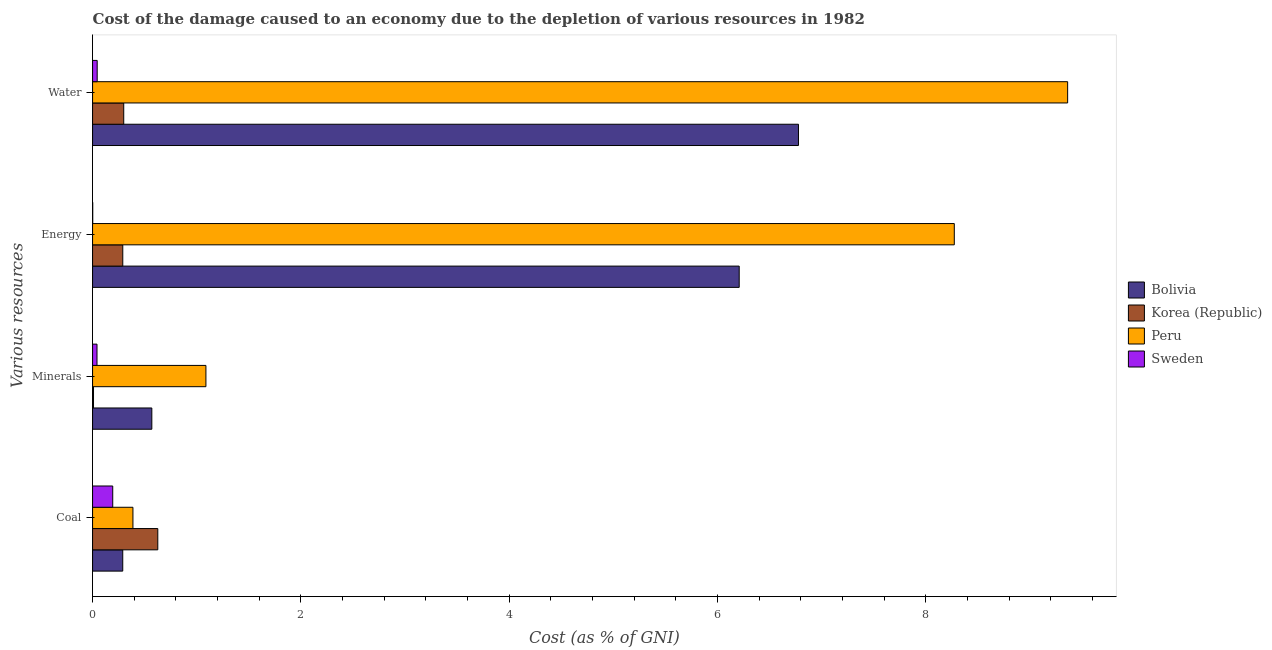How many groups of bars are there?
Ensure brevity in your answer.  4. How many bars are there on the 4th tick from the bottom?
Offer a very short reply. 4. What is the label of the 2nd group of bars from the top?
Your answer should be compact. Energy. What is the cost of damage due to depletion of minerals in Peru?
Your answer should be compact. 1.09. Across all countries, what is the maximum cost of damage due to depletion of energy?
Your response must be concise. 8.27. Across all countries, what is the minimum cost of damage due to depletion of minerals?
Keep it short and to the point. 0.01. What is the total cost of damage due to depletion of coal in the graph?
Provide a short and direct response. 1.5. What is the difference between the cost of damage due to depletion of water in Sweden and that in Bolivia?
Make the answer very short. -6.73. What is the difference between the cost of damage due to depletion of minerals in Sweden and the cost of damage due to depletion of water in Korea (Republic)?
Make the answer very short. -0.26. What is the average cost of damage due to depletion of minerals per country?
Your answer should be very brief. 0.43. What is the difference between the cost of damage due to depletion of energy and cost of damage due to depletion of coal in Bolivia?
Give a very brief answer. 5.92. What is the ratio of the cost of damage due to depletion of energy in Sweden to that in Korea (Republic)?
Your response must be concise. 0.01. What is the difference between the highest and the second highest cost of damage due to depletion of energy?
Make the answer very short. 2.06. What is the difference between the highest and the lowest cost of damage due to depletion of coal?
Provide a short and direct response. 0.43. In how many countries, is the cost of damage due to depletion of minerals greater than the average cost of damage due to depletion of minerals taken over all countries?
Provide a succinct answer. 2. Is it the case that in every country, the sum of the cost of damage due to depletion of minerals and cost of damage due to depletion of coal is greater than the sum of cost of damage due to depletion of water and cost of damage due to depletion of energy?
Keep it short and to the point. No. What does the 2nd bar from the top in Water represents?
Offer a very short reply. Peru. Is it the case that in every country, the sum of the cost of damage due to depletion of coal and cost of damage due to depletion of minerals is greater than the cost of damage due to depletion of energy?
Your response must be concise. No. How many bars are there?
Your response must be concise. 16. How many countries are there in the graph?
Offer a very short reply. 4. What is the difference between two consecutive major ticks on the X-axis?
Offer a terse response. 2. Are the values on the major ticks of X-axis written in scientific E-notation?
Give a very brief answer. No. Does the graph contain any zero values?
Provide a succinct answer. No. Does the graph contain grids?
Keep it short and to the point. No. How are the legend labels stacked?
Offer a terse response. Vertical. What is the title of the graph?
Your answer should be compact. Cost of the damage caused to an economy due to the depletion of various resources in 1982 . Does "Finland" appear as one of the legend labels in the graph?
Offer a very short reply. No. What is the label or title of the X-axis?
Your answer should be very brief. Cost (as % of GNI). What is the label or title of the Y-axis?
Give a very brief answer. Various resources. What is the Cost (as % of GNI) of Bolivia in Coal?
Your answer should be compact. 0.29. What is the Cost (as % of GNI) in Korea (Republic) in Coal?
Offer a terse response. 0.63. What is the Cost (as % of GNI) in Peru in Coal?
Offer a very short reply. 0.39. What is the Cost (as % of GNI) of Sweden in Coal?
Ensure brevity in your answer.  0.19. What is the Cost (as % of GNI) of Bolivia in Minerals?
Keep it short and to the point. 0.57. What is the Cost (as % of GNI) in Korea (Republic) in Minerals?
Keep it short and to the point. 0.01. What is the Cost (as % of GNI) in Peru in Minerals?
Keep it short and to the point. 1.09. What is the Cost (as % of GNI) in Sweden in Minerals?
Offer a terse response. 0.04. What is the Cost (as % of GNI) of Bolivia in Energy?
Give a very brief answer. 6.21. What is the Cost (as % of GNI) of Korea (Republic) in Energy?
Offer a very short reply. 0.29. What is the Cost (as % of GNI) in Peru in Energy?
Offer a terse response. 8.27. What is the Cost (as % of GNI) in Sweden in Energy?
Provide a succinct answer. 0. What is the Cost (as % of GNI) of Bolivia in Water?
Your answer should be very brief. 6.78. What is the Cost (as % of GNI) of Korea (Republic) in Water?
Your answer should be very brief. 0.3. What is the Cost (as % of GNI) in Peru in Water?
Provide a short and direct response. 9.36. What is the Cost (as % of GNI) of Sweden in Water?
Keep it short and to the point. 0.04. Across all Various resources, what is the maximum Cost (as % of GNI) in Bolivia?
Give a very brief answer. 6.78. Across all Various resources, what is the maximum Cost (as % of GNI) of Korea (Republic)?
Give a very brief answer. 0.63. Across all Various resources, what is the maximum Cost (as % of GNI) of Peru?
Keep it short and to the point. 9.36. Across all Various resources, what is the maximum Cost (as % of GNI) in Sweden?
Give a very brief answer. 0.19. Across all Various resources, what is the minimum Cost (as % of GNI) in Bolivia?
Provide a short and direct response. 0.29. Across all Various resources, what is the minimum Cost (as % of GNI) in Korea (Republic)?
Your answer should be very brief. 0.01. Across all Various resources, what is the minimum Cost (as % of GNI) in Peru?
Provide a succinct answer. 0.39. Across all Various resources, what is the minimum Cost (as % of GNI) of Sweden?
Your response must be concise. 0. What is the total Cost (as % of GNI) of Bolivia in the graph?
Provide a succinct answer. 13.84. What is the total Cost (as % of GNI) in Korea (Republic) in the graph?
Your answer should be very brief. 1.22. What is the total Cost (as % of GNI) in Peru in the graph?
Keep it short and to the point. 19.11. What is the total Cost (as % of GNI) of Sweden in the graph?
Your answer should be very brief. 0.28. What is the difference between the Cost (as % of GNI) in Bolivia in Coal and that in Minerals?
Make the answer very short. -0.28. What is the difference between the Cost (as % of GNI) of Korea (Republic) in Coal and that in Minerals?
Provide a short and direct response. 0.62. What is the difference between the Cost (as % of GNI) of Peru in Coal and that in Minerals?
Ensure brevity in your answer.  -0.7. What is the difference between the Cost (as % of GNI) in Sweden in Coal and that in Minerals?
Offer a terse response. 0.15. What is the difference between the Cost (as % of GNI) of Bolivia in Coal and that in Energy?
Make the answer very short. -5.92. What is the difference between the Cost (as % of GNI) in Korea (Republic) in Coal and that in Energy?
Provide a short and direct response. 0.34. What is the difference between the Cost (as % of GNI) in Peru in Coal and that in Energy?
Make the answer very short. -7.88. What is the difference between the Cost (as % of GNI) of Sweden in Coal and that in Energy?
Keep it short and to the point. 0.19. What is the difference between the Cost (as % of GNI) of Bolivia in Coal and that in Water?
Give a very brief answer. -6.49. What is the difference between the Cost (as % of GNI) in Korea (Republic) in Coal and that in Water?
Provide a succinct answer. 0.33. What is the difference between the Cost (as % of GNI) in Peru in Coal and that in Water?
Offer a very short reply. -8.97. What is the difference between the Cost (as % of GNI) of Sweden in Coal and that in Water?
Keep it short and to the point. 0.15. What is the difference between the Cost (as % of GNI) in Bolivia in Minerals and that in Energy?
Your response must be concise. -5.64. What is the difference between the Cost (as % of GNI) of Korea (Republic) in Minerals and that in Energy?
Your response must be concise. -0.28. What is the difference between the Cost (as % of GNI) in Peru in Minerals and that in Energy?
Offer a very short reply. -7.18. What is the difference between the Cost (as % of GNI) in Sweden in Minerals and that in Energy?
Keep it short and to the point. 0.04. What is the difference between the Cost (as % of GNI) of Bolivia in Minerals and that in Water?
Your answer should be compact. -6.21. What is the difference between the Cost (as % of GNI) in Korea (Republic) in Minerals and that in Water?
Provide a short and direct response. -0.29. What is the difference between the Cost (as % of GNI) of Peru in Minerals and that in Water?
Your answer should be compact. -8.27. What is the difference between the Cost (as % of GNI) of Sweden in Minerals and that in Water?
Offer a very short reply. -0. What is the difference between the Cost (as % of GNI) of Bolivia in Energy and that in Water?
Make the answer very short. -0.57. What is the difference between the Cost (as % of GNI) in Korea (Republic) in Energy and that in Water?
Give a very brief answer. -0.01. What is the difference between the Cost (as % of GNI) in Peru in Energy and that in Water?
Your answer should be very brief. -1.09. What is the difference between the Cost (as % of GNI) of Sweden in Energy and that in Water?
Keep it short and to the point. -0.04. What is the difference between the Cost (as % of GNI) in Bolivia in Coal and the Cost (as % of GNI) in Korea (Republic) in Minerals?
Your response must be concise. 0.28. What is the difference between the Cost (as % of GNI) in Bolivia in Coal and the Cost (as % of GNI) in Peru in Minerals?
Make the answer very short. -0.8. What is the difference between the Cost (as % of GNI) of Bolivia in Coal and the Cost (as % of GNI) of Sweden in Minerals?
Offer a very short reply. 0.25. What is the difference between the Cost (as % of GNI) in Korea (Republic) in Coal and the Cost (as % of GNI) in Peru in Minerals?
Your answer should be compact. -0.46. What is the difference between the Cost (as % of GNI) in Korea (Republic) in Coal and the Cost (as % of GNI) in Sweden in Minerals?
Offer a very short reply. 0.58. What is the difference between the Cost (as % of GNI) in Peru in Coal and the Cost (as % of GNI) in Sweden in Minerals?
Keep it short and to the point. 0.34. What is the difference between the Cost (as % of GNI) in Bolivia in Coal and the Cost (as % of GNI) in Korea (Republic) in Energy?
Keep it short and to the point. -0. What is the difference between the Cost (as % of GNI) in Bolivia in Coal and the Cost (as % of GNI) in Peru in Energy?
Offer a terse response. -7.98. What is the difference between the Cost (as % of GNI) in Bolivia in Coal and the Cost (as % of GNI) in Sweden in Energy?
Your answer should be compact. 0.29. What is the difference between the Cost (as % of GNI) in Korea (Republic) in Coal and the Cost (as % of GNI) in Peru in Energy?
Offer a terse response. -7.65. What is the difference between the Cost (as % of GNI) in Korea (Republic) in Coal and the Cost (as % of GNI) in Sweden in Energy?
Provide a short and direct response. 0.62. What is the difference between the Cost (as % of GNI) of Peru in Coal and the Cost (as % of GNI) of Sweden in Energy?
Provide a short and direct response. 0.39. What is the difference between the Cost (as % of GNI) in Bolivia in Coal and the Cost (as % of GNI) in Korea (Republic) in Water?
Make the answer very short. -0.01. What is the difference between the Cost (as % of GNI) in Bolivia in Coal and the Cost (as % of GNI) in Peru in Water?
Give a very brief answer. -9.07. What is the difference between the Cost (as % of GNI) in Bolivia in Coal and the Cost (as % of GNI) in Sweden in Water?
Provide a short and direct response. 0.25. What is the difference between the Cost (as % of GNI) in Korea (Republic) in Coal and the Cost (as % of GNI) in Peru in Water?
Your answer should be compact. -8.73. What is the difference between the Cost (as % of GNI) of Korea (Republic) in Coal and the Cost (as % of GNI) of Sweden in Water?
Offer a very short reply. 0.58. What is the difference between the Cost (as % of GNI) of Peru in Coal and the Cost (as % of GNI) of Sweden in Water?
Offer a terse response. 0.34. What is the difference between the Cost (as % of GNI) of Bolivia in Minerals and the Cost (as % of GNI) of Korea (Republic) in Energy?
Give a very brief answer. 0.28. What is the difference between the Cost (as % of GNI) of Bolivia in Minerals and the Cost (as % of GNI) of Peru in Energy?
Keep it short and to the point. -7.7. What is the difference between the Cost (as % of GNI) in Bolivia in Minerals and the Cost (as % of GNI) in Sweden in Energy?
Offer a terse response. 0.57. What is the difference between the Cost (as % of GNI) of Korea (Republic) in Minerals and the Cost (as % of GNI) of Peru in Energy?
Give a very brief answer. -8.26. What is the difference between the Cost (as % of GNI) in Korea (Republic) in Minerals and the Cost (as % of GNI) in Sweden in Energy?
Offer a very short reply. 0.01. What is the difference between the Cost (as % of GNI) of Peru in Minerals and the Cost (as % of GNI) of Sweden in Energy?
Your answer should be very brief. 1.09. What is the difference between the Cost (as % of GNI) in Bolivia in Minerals and the Cost (as % of GNI) in Korea (Republic) in Water?
Keep it short and to the point. 0.27. What is the difference between the Cost (as % of GNI) of Bolivia in Minerals and the Cost (as % of GNI) of Peru in Water?
Provide a succinct answer. -8.79. What is the difference between the Cost (as % of GNI) of Bolivia in Minerals and the Cost (as % of GNI) of Sweden in Water?
Provide a short and direct response. 0.52. What is the difference between the Cost (as % of GNI) of Korea (Republic) in Minerals and the Cost (as % of GNI) of Peru in Water?
Provide a succinct answer. -9.35. What is the difference between the Cost (as % of GNI) of Korea (Republic) in Minerals and the Cost (as % of GNI) of Sweden in Water?
Give a very brief answer. -0.04. What is the difference between the Cost (as % of GNI) in Peru in Minerals and the Cost (as % of GNI) in Sweden in Water?
Offer a very short reply. 1.04. What is the difference between the Cost (as % of GNI) of Bolivia in Energy and the Cost (as % of GNI) of Korea (Republic) in Water?
Offer a terse response. 5.91. What is the difference between the Cost (as % of GNI) of Bolivia in Energy and the Cost (as % of GNI) of Peru in Water?
Ensure brevity in your answer.  -3.15. What is the difference between the Cost (as % of GNI) in Bolivia in Energy and the Cost (as % of GNI) in Sweden in Water?
Your answer should be compact. 6.16. What is the difference between the Cost (as % of GNI) of Korea (Republic) in Energy and the Cost (as % of GNI) of Peru in Water?
Give a very brief answer. -9.07. What is the difference between the Cost (as % of GNI) in Korea (Republic) in Energy and the Cost (as % of GNI) in Sweden in Water?
Give a very brief answer. 0.25. What is the difference between the Cost (as % of GNI) of Peru in Energy and the Cost (as % of GNI) of Sweden in Water?
Offer a terse response. 8.23. What is the average Cost (as % of GNI) in Bolivia per Various resources?
Keep it short and to the point. 3.46. What is the average Cost (as % of GNI) in Korea (Republic) per Various resources?
Make the answer very short. 0.31. What is the average Cost (as % of GNI) of Peru per Various resources?
Ensure brevity in your answer.  4.78. What is the average Cost (as % of GNI) of Sweden per Various resources?
Your answer should be compact. 0.07. What is the difference between the Cost (as % of GNI) of Bolivia and Cost (as % of GNI) of Korea (Republic) in Coal?
Offer a terse response. -0.34. What is the difference between the Cost (as % of GNI) of Bolivia and Cost (as % of GNI) of Peru in Coal?
Your answer should be very brief. -0.1. What is the difference between the Cost (as % of GNI) of Bolivia and Cost (as % of GNI) of Sweden in Coal?
Give a very brief answer. 0.1. What is the difference between the Cost (as % of GNI) of Korea (Republic) and Cost (as % of GNI) of Peru in Coal?
Your answer should be compact. 0.24. What is the difference between the Cost (as % of GNI) in Korea (Republic) and Cost (as % of GNI) in Sweden in Coal?
Keep it short and to the point. 0.43. What is the difference between the Cost (as % of GNI) of Peru and Cost (as % of GNI) of Sweden in Coal?
Offer a very short reply. 0.19. What is the difference between the Cost (as % of GNI) in Bolivia and Cost (as % of GNI) in Korea (Republic) in Minerals?
Make the answer very short. 0.56. What is the difference between the Cost (as % of GNI) in Bolivia and Cost (as % of GNI) in Peru in Minerals?
Your answer should be compact. -0.52. What is the difference between the Cost (as % of GNI) of Bolivia and Cost (as % of GNI) of Sweden in Minerals?
Offer a terse response. 0.53. What is the difference between the Cost (as % of GNI) in Korea (Republic) and Cost (as % of GNI) in Peru in Minerals?
Ensure brevity in your answer.  -1.08. What is the difference between the Cost (as % of GNI) of Korea (Republic) and Cost (as % of GNI) of Sweden in Minerals?
Ensure brevity in your answer.  -0.03. What is the difference between the Cost (as % of GNI) in Peru and Cost (as % of GNI) in Sweden in Minerals?
Give a very brief answer. 1.05. What is the difference between the Cost (as % of GNI) of Bolivia and Cost (as % of GNI) of Korea (Republic) in Energy?
Provide a succinct answer. 5.92. What is the difference between the Cost (as % of GNI) of Bolivia and Cost (as % of GNI) of Peru in Energy?
Provide a short and direct response. -2.06. What is the difference between the Cost (as % of GNI) in Bolivia and Cost (as % of GNI) in Sweden in Energy?
Your response must be concise. 6.21. What is the difference between the Cost (as % of GNI) of Korea (Republic) and Cost (as % of GNI) of Peru in Energy?
Offer a terse response. -7.98. What is the difference between the Cost (as % of GNI) in Korea (Republic) and Cost (as % of GNI) in Sweden in Energy?
Your answer should be compact. 0.29. What is the difference between the Cost (as % of GNI) in Peru and Cost (as % of GNI) in Sweden in Energy?
Keep it short and to the point. 8.27. What is the difference between the Cost (as % of GNI) of Bolivia and Cost (as % of GNI) of Korea (Republic) in Water?
Your answer should be very brief. 6.48. What is the difference between the Cost (as % of GNI) in Bolivia and Cost (as % of GNI) in Peru in Water?
Give a very brief answer. -2.58. What is the difference between the Cost (as % of GNI) in Bolivia and Cost (as % of GNI) in Sweden in Water?
Your answer should be very brief. 6.73. What is the difference between the Cost (as % of GNI) of Korea (Republic) and Cost (as % of GNI) of Peru in Water?
Provide a short and direct response. -9.06. What is the difference between the Cost (as % of GNI) of Korea (Republic) and Cost (as % of GNI) of Sweden in Water?
Ensure brevity in your answer.  0.25. What is the difference between the Cost (as % of GNI) in Peru and Cost (as % of GNI) in Sweden in Water?
Ensure brevity in your answer.  9.32. What is the ratio of the Cost (as % of GNI) in Bolivia in Coal to that in Minerals?
Give a very brief answer. 0.51. What is the ratio of the Cost (as % of GNI) in Korea (Republic) in Coal to that in Minerals?
Ensure brevity in your answer.  68.47. What is the ratio of the Cost (as % of GNI) of Peru in Coal to that in Minerals?
Keep it short and to the point. 0.36. What is the ratio of the Cost (as % of GNI) of Sweden in Coal to that in Minerals?
Provide a short and direct response. 4.54. What is the ratio of the Cost (as % of GNI) in Bolivia in Coal to that in Energy?
Keep it short and to the point. 0.05. What is the ratio of the Cost (as % of GNI) of Korea (Republic) in Coal to that in Energy?
Your answer should be compact. 2.16. What is the ratio of the Cost (as % of GNI) in Peru in Coal to that in Energy?
Ensure brevity in your answer.  0.05. What is the ratio of the Cost (as % of GNI) of Sweden in Coal to that in Energy?
Provide a succinct answer. 115.75. What is the ratio of the Cost (as % of GNI) in Bolivia in Coal to that in Water?
Provide a short and direct response. 0.04. What is the ratio of the Cost (as % of GNI) of Korea (Republic) in Coal to that in Water?
Give a very brief answer. 2.09. What is the ratio of the Cost (as % of GNI) in Peru in Coal to that in Water?
Provide a short and direct response. 0.04. What is the ratio of the Cost (as % of GNI) of Sweden in Coal to that in Water?
Provide a succinct answer. 4.37. What is the ratio of the Cost (as % of GNI) of Bolivia in Minerals to that in Energy?
Offer a terse response. 0.09. What is the ratio of the Cost (as % of GNI) of Korea (Republic) in Minerals to that in Energy?
Keep it short and to the point. 0.03. What is the ratio of the Cost (as % of GNI) of Peru in Minerals to that in Energy?
Make the answer very short. 0.13. What is the ratio of the Cost (as % of GNI) in Sweden in Minerals to that in Energy?
Provide a succinct answer. 25.48. What is the ratio of the Cost (as % of GNI) in Bolivia in Minerals to that in Water?
Provide a short and direct response. 0.08. What is the ratio of the Cost (as % of GNI) in Korea (Republic) in Minerals to that in Water?
Give a very brief answer. 0.03. What is the ratio of the Cost (as % of GNI) of Peru in Minerals to that in Water?
Your answer should be very brief. 0.12. What is the ratio of the Cost (as % of GNI) of Sweden in Minerals to that in Water?
Provide a short and direct response. 0.96. What is the ratio of the Cost (as % of GNI) in Bolivia in Energy to that in Water?
Offer a very short reply. 0.92. What is the ratio of the Cost (as % of GNI) of Korea (Republic) in Energy to that in Water?
Keep it short and to the point. 0.97. What is the ratio of the Cost (as % of GNI) of Peru in Energy to that in Water?
Offer a terse response. 0.88. What is the ratio of the Cost (as % of GNI) of Sweden in Energy to that in Water?
Keep it short and to the point. 0.04. What is the difference between the highest and the second highest Cost (as % of GNI) of Bolivia?
Your response must be concise. 0.57. What is the difference between the highest and the second highest Cost (as % of GNI) of Korea (Republic)?
Keep it short and to the point. 0.33. What is the difference between the highest and the second highest Cost (as % of GNI) of Peru?
Make the answer very short. 1.09. What is the difference between the highest and the second highest Cost (as % of GNI) of Sweden?
Provide a succinct answer. 0.15. What is the difference between the highest and the lowest Cost (as % of GNI) in Bolivia?
Keep it short and to the point. 6.49. What is the difference between the highest and the lowest Cost (as % of GNI) in Korea (Republic)?
Provide a short and direct response. 0.62. What is the difference between the highest and the lowest Cost (as % of GNI) in Peru?
Offer a terse response. 8.97. What is the difference between the highest and the lowest Cost (as % of GNI) of Sweden?
Your answer should be very brief. 0.19. 